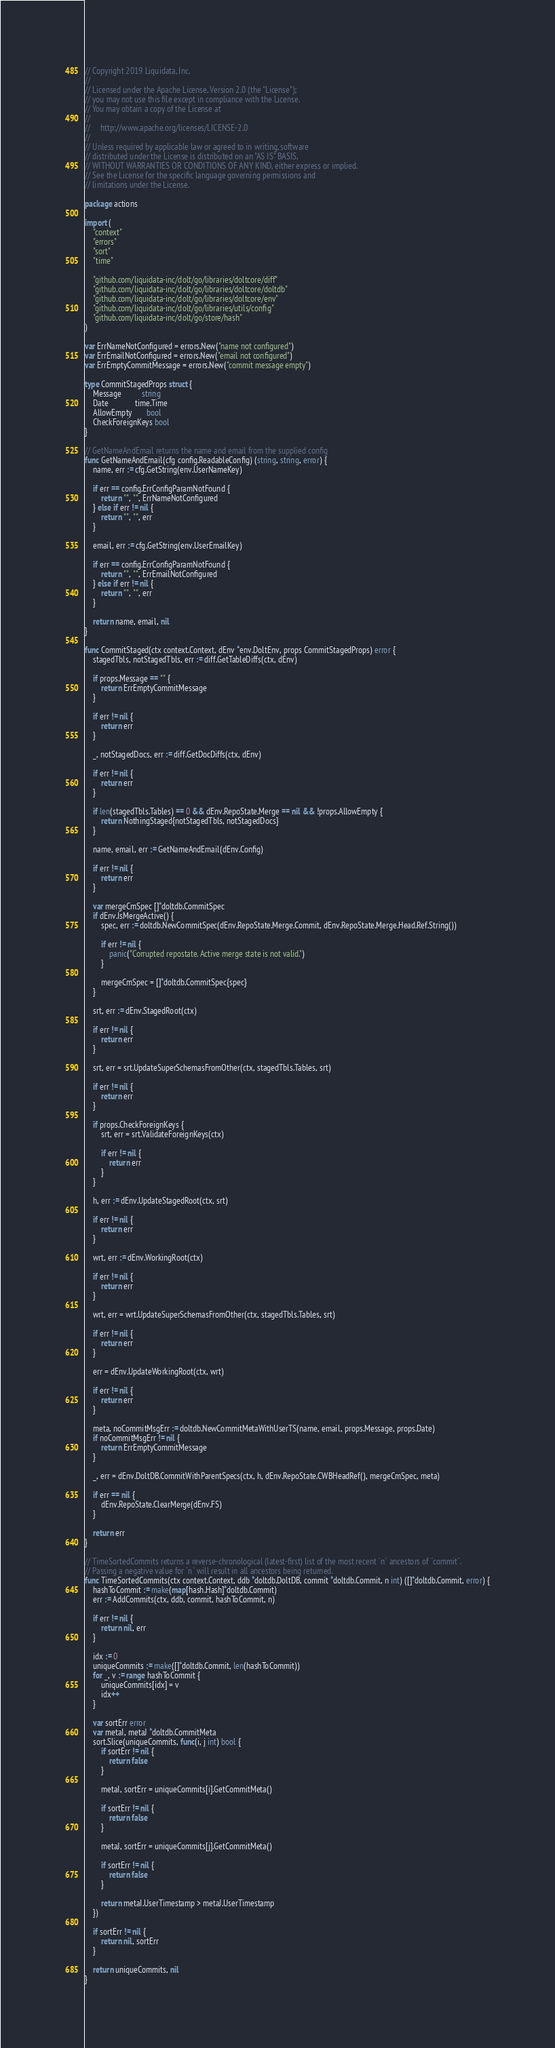Convert code to text. <code><loc_0><loc_0><loc_500><loc_500><_Go_>// Copyright 2019 Liquidata, Inc.
//
// Licensed under the Apache License, Version 2.0 (the "License");
// you may not use this file except in compliance with the License.
// You may obtain a copy of the License at
//
//     http://www.apache.org/licenses/LICENSE-2.0
//
// Unless required by applicable law or agreed to in writing, software
// distributed under the License is distributed on an "AS IS" BASIS,
// WITHOUT WARRANTIES OR CONDITIONS OF ANY KIND, either express or implied.
// See the License for the specific language governing permissions and
// limitations under the License.

package actions

import (
	"context"
	"errors"
	"sort"
	"time"

	"github.com/liquidata-inc/dolt/go/libraries/doltcore/diff"
	"github.com/liquidata-inc/dolt/go/libraries/doltcore/doltdb"
	"github.com/liquidata-inc/dolt/go/libraries/doltcore/env"
	"github.com/liquidata-inc/dolt/go/libraries/utils/config"
	"github.com/liquidata-inc/dolt/go/store/hash"
)

var ErrNameNotConfigured = errors.New("name not configured")
var ErrEmailNotConfigured = errors.New("email not configured")
var ErrEmptyCommitMessage = errors.New("commit message empty")

type CommitStagedProps struct {
	Message          string
	Date             time.Time
	AllowEmpty       bool
	CheckForeignKeys bool
}

// GetNameAndEmail returns the name and email from the supplied config
func GetNameAndEmail(cfg config.ReadableConfig) (string, string, error) {
	name, err := cfg.GetString(env.UserNameKey)

	if err == config.ErrConfigParamNotFound {
		return "", "", ErrNameNotConfigured
	} else if err != nil {
		return "", "", err
	}

	email, err := cfg.GetString(env.UserEmailKey)

	if err == config.ErrConfigParamNotFound {
		return "", "", ErrEmailNotConfigured
	} else if err != nil {
		return "", "", err
	}

	return name, email, nil
}

func CommitStaged(ctx context.Context, dEnv *env.DoltEnv, props CommitStagedProps) error {
	stagedTbls, notStagedTbls, err := diff.GetTableDiffs(ctx, dEnv)

	if props.Message == "" {
		return ErrEmptyCommitMessage
	}

	if err != nil {
		return err
	}

	_, notStagedDocs, err := diff.GetDocDiffs(ctx, dEnv)

	if err != nil {
		return err
	}

	if len(stagedTbls.Tables) == 0 && dEnv.RepoState.Merge == nil && !props.AllowEmpty {
		return NothingStaged{notStagedTbls, notStagedDocs}
	}

	name, email, err := GetNameAndEmail(dEnv.Config)

	if err != nil {
		return err
	}

	var mergeCmSpec []*doltdb.CommitSpec
	if dEnv.IsMergeActive() {
		spec, err := doltdb.NewCommitSpec(dEnv.RepoState.Merge.Commit, dEnv.RepoState.Merge.Head.Ref.String())

		if err != nil {
			panic("Corrupted repostate. Active merge state is not valid.")
		}

		mergeCmSpec = []*doltdb.CommitSpec{spec}
	}

	srt, err := dEnv.StagedRoot(ctx)

	if err != nil {
		return err
	}

	srt, err = srt.UpdateSuperSchemasFromOther(ctx, stagedTbls.Tables, srt)

	if err != nil {
		return err
	}

	if props.CheckForeignKeys {
		srt, err = srt.ValidateForeignKeys(ctx)

		if err != nil {
			return err
		}
	}

	h, err := dEnv.UpdateStagedRoot(ctx, srt)

	if err != nil {
		return err
	}

	wrt, err := dEnv.WorkingRoot(ctx)

	if err != nil {
		return err
	}

	wrt, err = wrt.UpdateSuperSchemasFromOther(ctx, stagedTbls.Tables, srt)

	if err != nil {
		return err
	}

	err = dEnv.UpdateWorkingRoot(ctx, wrt)

	if err != nil {
		return err
	}

	meta, noCommitMsgErr := doltdb.NewCommitMetaWithUserTS(name, email, props.Message, props.Date)
	if noCommitMsgErr != nil {
		return ErrEmptyCommitMessage
	}

	_, err = dEnv.DoltDB.CommitWithParentSpecs(ctx, h, dEnv.RepoState.CWBHeadRef(), mergeCmSpec, meta)

	if err == nil {
		dEnv.RepoState.ClearMerge(dEnv.FS)
	}

	return err
}

// TimeSortedCommits returns a reverse-chronological (latest-first) list of the most recent `n` ancestors of `commit`.
// Passing a negative value for `n` will result in all ancestors being returned.
func TimeSortedCommits(ctx context.Context, ddb *doltdb.DoltDB, commit *doltdb.Commit, n int) ([]*doltdb.Commit, error) {
	hashToCommit := make(map[hash.Hash]*doltdb.Commit)
	err := AddCommits(ctx, ddb, commit, hashToCommit, n)

	if err != nil {
		return nil, err
	}

	idx := 0
	uniqueCommits := make([]*doltdb.Commit, len(hashToCommit))
	for _, v := range hashToCommit {
		uniqueCommits[idx] = v
		idx++
	}

	var sortErr error
	var metaI, metaJ *doltdb.CommitMeta
	sort.Slice(uniqueCommits, func(i, j int) bool {
		if sortErr != nil {
			return false
		}

		metaI, sortErr = uniqueCommits[i].GetCommitMeta()

		if sortErr != nil {
			return false
		}

		metaJ, sortErr = uniqueCommits[j].GetCommitMeta()

		if sortErr != nil {
			return false
		}

		return metaI.UserTimestamp > metaJ.UserTimestamp
	})

	if sortErr != nil {
		return nil, sortErr
	}

	return uniqueCommits, nil
}
</code> 